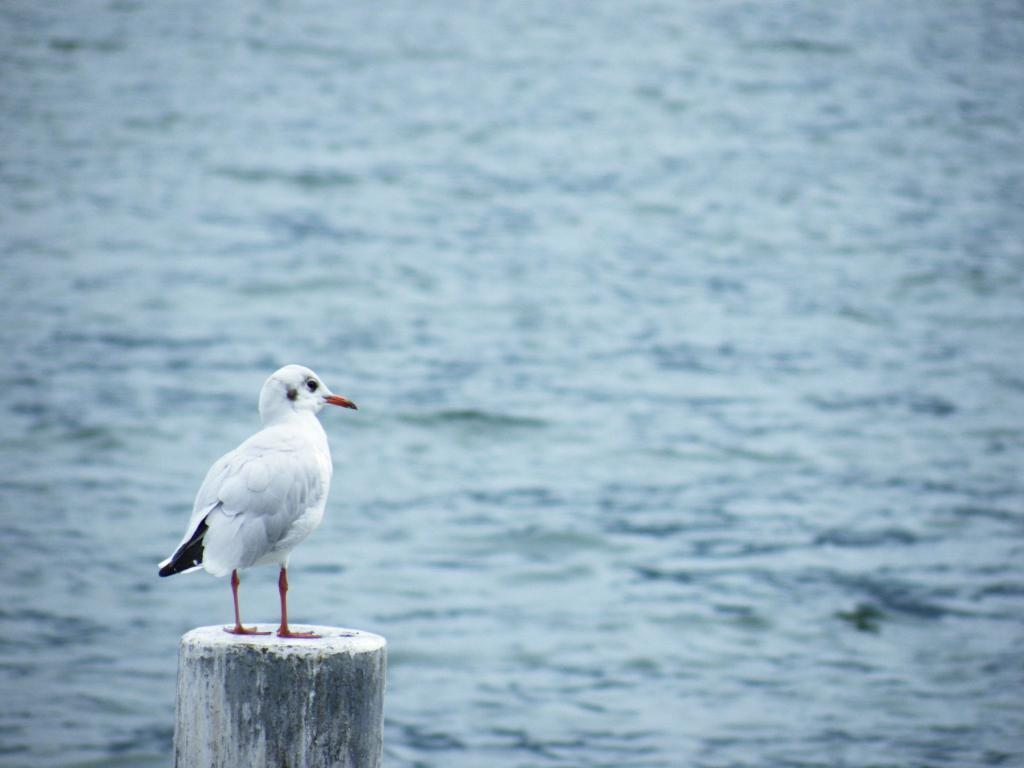What is on the wooden stand in the image? There is a bird on a wooden stand in the image. What can be seen in the background of the image? Water is visible in the background of the image. What type of chalk is the bird using to draw on the wooden stand? There is no chalk present in the image, and the bird is not drawing on the wooden stand. 